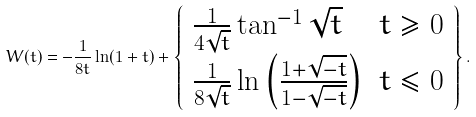Convert formula to latex. <formula><loc_0><loc_0><loc_500><loc_500>W ( t ) = - \frac { 1 } { 8 t } \ln ( 1 + t ) + \left \{ \begin{array} { l l r } \frac { 1 } { 4 \sqrt { t } } \tan ^ { - 1 } \sqrt { t } & t \geqslant 0 \\ \frac { 1 } { 8 \sqrt { t } } \ln \left ( \frac { 1 + \sqrt { - t } } { 1 - \sqrt { - t } } \right ) & t \leqslant 0 \end{array} \right \} .</formula> 